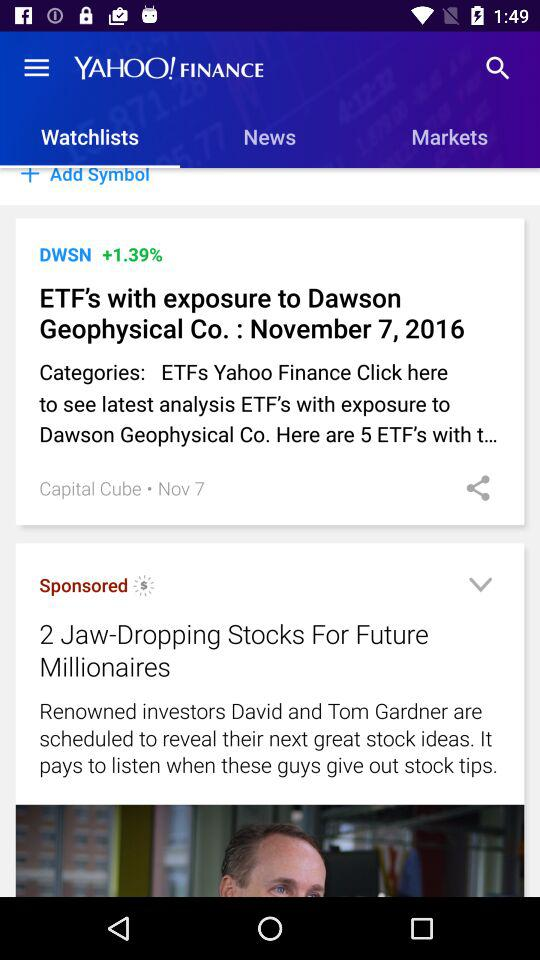Which option is selected in "YAHOO! FINANCE"? In "YAHOO! FINANCE", "Watchlists" is selected. 